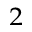Convert formula to latex. <formula><loc_0><loc_0><loc_500><loc_500>^ { 2 }</formula> 